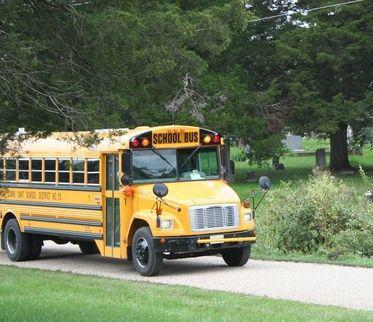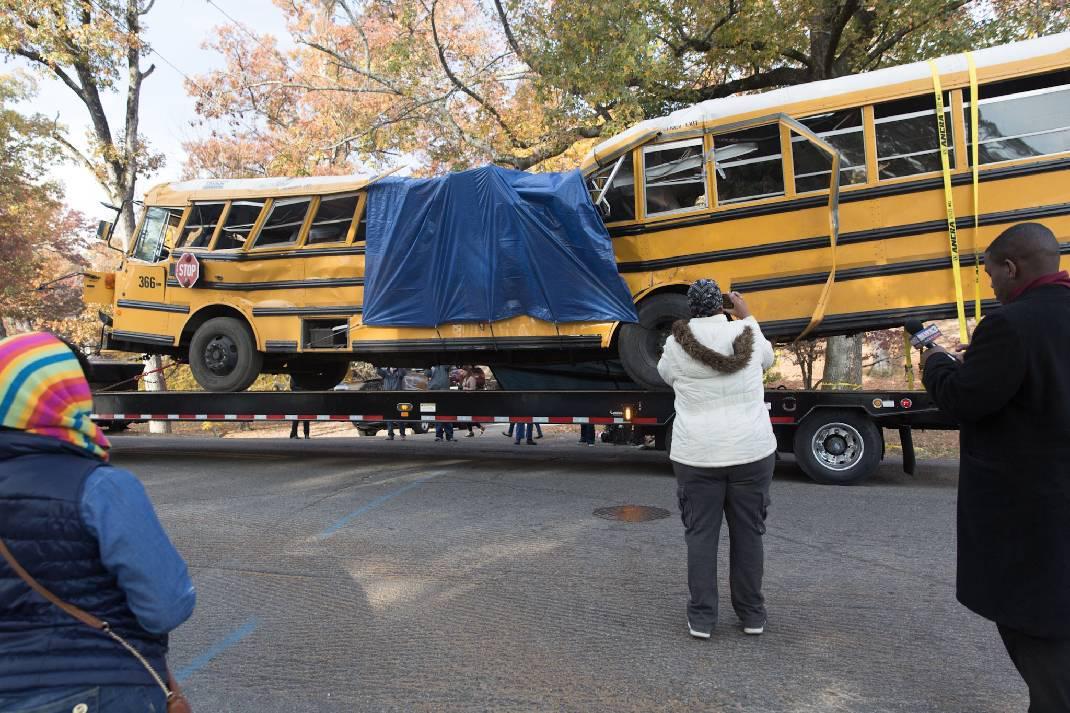The first image is the image on the left, the second image is the image on the right. For the images shown, is this caption "In three of the images, the school bus is laying on it's side." true? Answer yes or no. No. The first image is the image on the left, the second image is the image on the right. Examine the images to the left and right. Is the description "The right image contains a school bus that is flipped onto its side." accurate? Answer yes or no. No. 